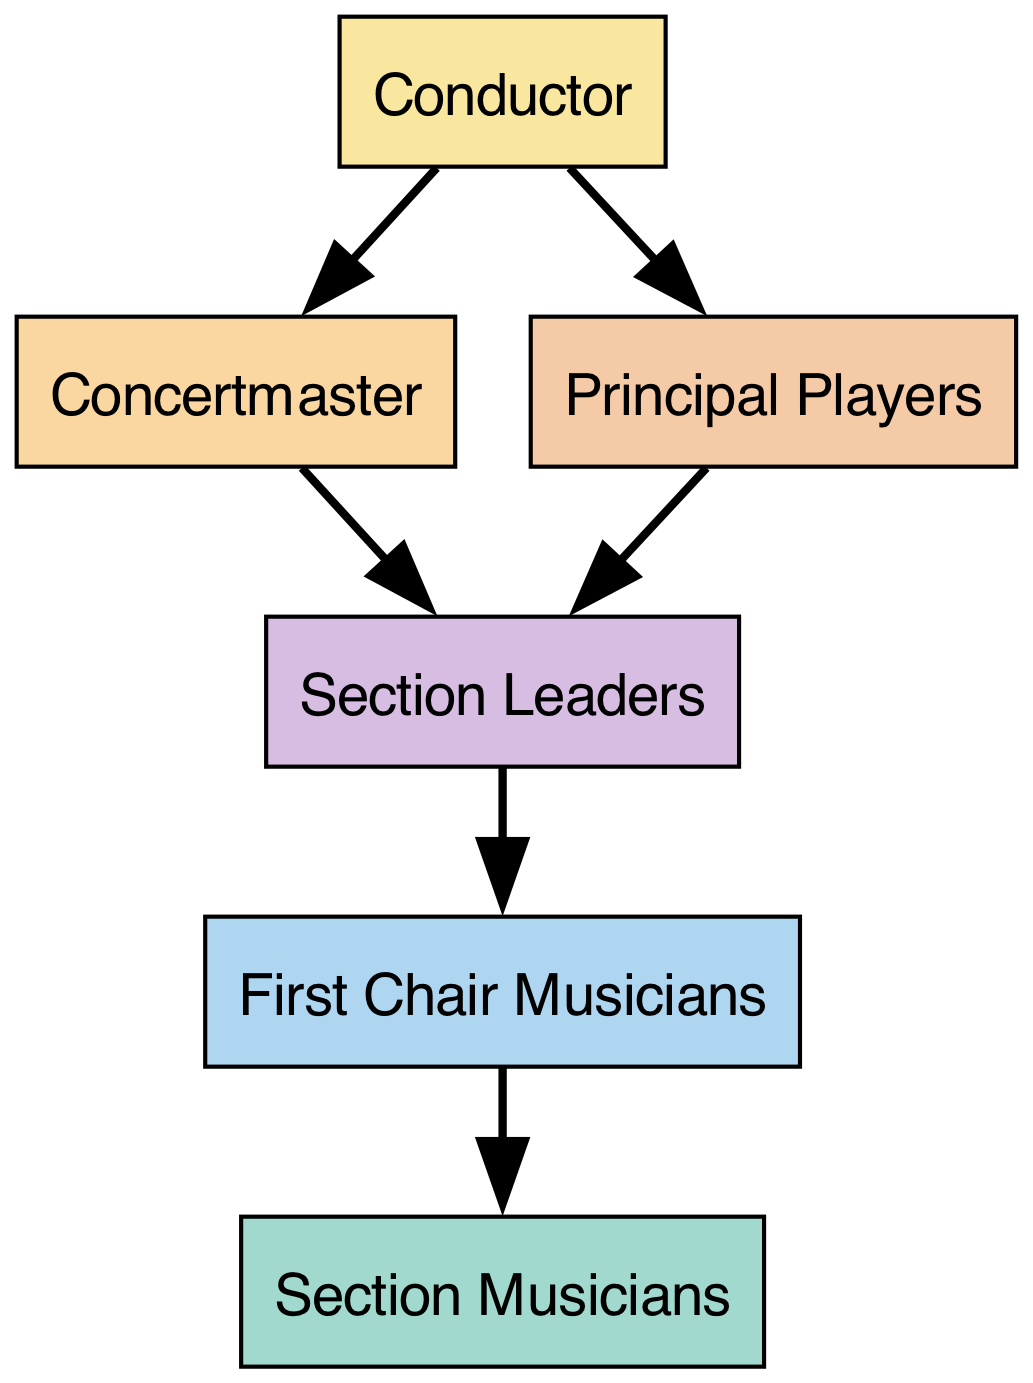What is the top position in the hierarchy? The diagram shows that the "Conductor" is at the top of the hierarchy, with arrows pointing down to "Concertmaster" and "Principal Players," indicating the flow of authority.
Answer: Conductor How many nodes are there in total? By counting each unique role in the diagram, we see six distinct nodes: "Conductor," "Concertmaster," "Principal Players," "Section Leaders," "First Chair Musicians," and "Section Musicians."
Answer: 6 Which role consumes the most other roles? The "Conductor" consumes both the "Concertmaster" and "Principal Players," while all other roles consume one or none, making it the role with the most consumption.
Answer: Conductor Who does the Concertmaster consume? The arrow from "Concertmaster" leads to "Section Leaders," indicating that "Concertmaster" directly consumes "Section Leaders."
Answer: Section Leaders What is the lowest role in the hierarchy? The "Section Musicians" have no roles pointed toward them, indicating that they are at the bottom of the hierarchy.
Answer: Section Musicians How many roles consume "Section Leaders"? The roles consuming "Section Leaders" are "Concertmaster" and "Principal Players," therefore there are two roles in total that consume them.
Answer: 2 Which role is directly beneath the Conductor? The arrows directed from the "Conductor" lead to "Concertmaster" and "Principal Players," showing that both roles are directly beneath the "Conductor."
Answer: Concertmaster and Principal Players What is the flow of authority from the Principal Players? From the "Principal Players," there are arrows leading to "Section Leaders," indicating the flow of authority downward toward "Section Leaders."
Answer: Section Leaders Identify the only roles that consume Section Musicians. Since "First Chair Musicians" is the only role that consumes "Section Musicians" as per the diagram, we identify them as the sole role.
Answer: First Chair Musicians 